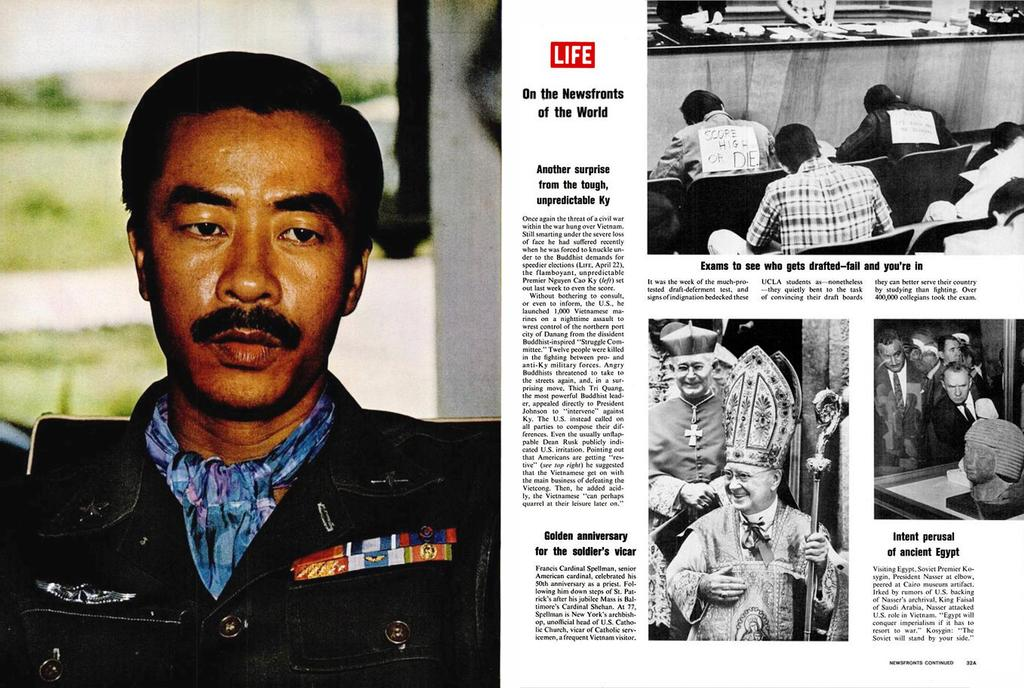Who is present on the left side of the image? There is a man on the left side of the image. What type of surface is on the left side of the image? There is grass and a white color wall on the left side of the image. What is on the right side of the image? There is a paper on the right side of the image. What can be seen on the paper? There are people depicted on the paper, and some matter is written on it. What type of underwear is the man wearing in the image? There is no information about the man's underwear in the image, so we cannot answer that question. Can you tell me what request the people on the paper are making? There is no indication of a request being made by the people depicted on the paper in the image. 